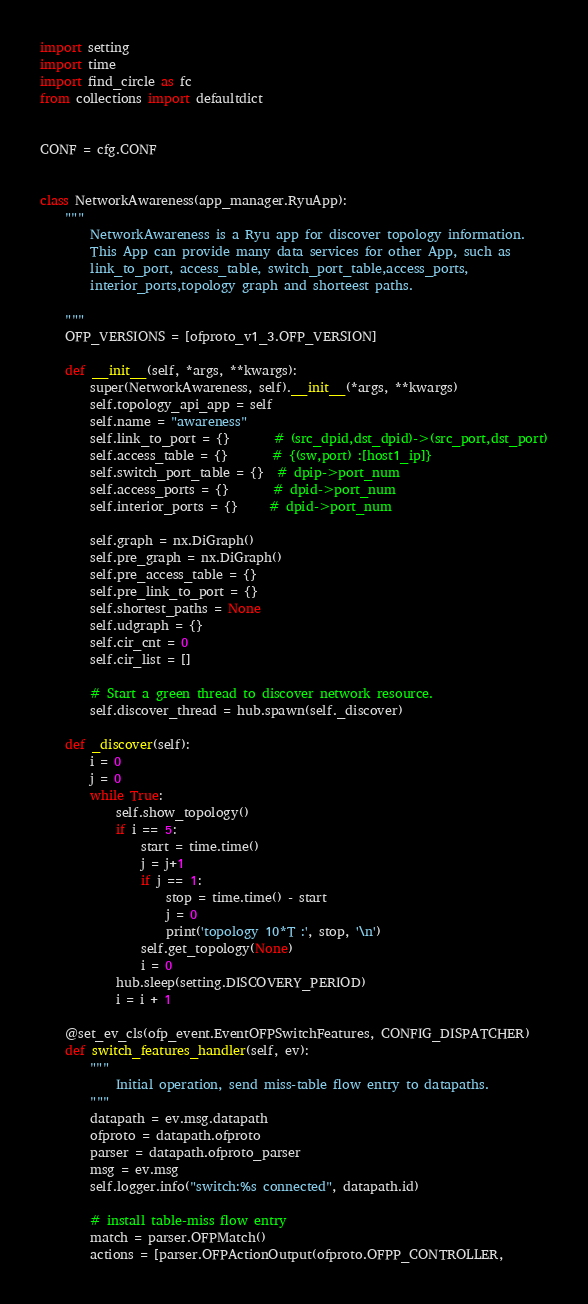<code> <loc_0><loc_0><loc_500><loc_500><_Python_>import setting
import time
import find_circle as fc
from collections import defaultdict


CONF = cfg.CONF


class NetworkAwareness(app_manager.RyuApp):
    """
        NetworkAwareness is a Ryu app for discover topology information.
        This App can provide many data services for other App, such as
        link_to_port, access_table, switch_port_table,access_ports,
        interior_ports,topology graph and shorteest paths.

    """
    OFP_VERSIONS = [ofproto_v1_3.OFP_VERSION]

    def __init__(self, *args, **kwargs):
        super(NetworkAwareness, self).__init__(*args, **kwargs)
        self.topology_api_app = self
        self.name = "awareness"
        self.link_to_port = {}       # (src_dpid,dst_dpid)->(src_port,dst_port)
        self.access_table = {}       # {(sw,port) :[host1_ip]}
        self.switch_port_table = {}  # dpip->port_num
        self.access_ports = {}       # dpid->port_num
        self.interior_ports = {}     # dpid->port_num

        self.graph = nx.DiGraph()
        self.pre_graph = nx.DiGraph()
        self.pre_access_table = {}
        self.pre_link_to_port = {}
        self.shortest_paths = None
        self.udgraph = {}
        self.cir_cnt = 0
        self.cir_list = []

        # Start a green thread to discover network resource.
        self.discover_thread = hub.spawn(self._discover)

    def _discover(self):
        i = 0
        j = 0
        while True:
            self.show_topology()
            if i == 5:
                start = time.time()
                j = j+1
                if j == 1: 
                    stop = time.time() - start
                    j = 0
                    print('topology 10*T :', stop, '\n')
                self.get_topology(None)
                i = 0
            hub.sleep(setting.DISCOVERY_PERIOD)
            i = i + 1

    @set_ev_cls(ofp_event.EventOFPSwitchFeatures, CONFIG_DISPATCHER)
    def switch_features_handler(self, ev):
        """
            Initial operation, send miss-table flow entry to datapaths.
        """
        datapath = ev.msg.datapath
        ofproto = datapath.ofproto
        parser = datapath.ofproto_parser
        msg = ev.msg
        self.logger.info("switch:%s connected", datapath.id)

        # install table-miss flow entry
        match = parser.OFPMatch()
        actions = [parser.OFPActionOutput(ofproto.OFPP_CONTROLLER,</code> 